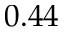Convert formula to latex. <formula><loc_0><loc_0><loc_500><loc_500>0 . 4 4</formula> 